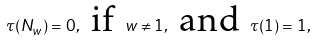Convert formula to latex. <formula><loc_0><loc_0><loc_500><loc_500>\tau ( N _ { w } ) = 0 , \text { if } w \neq 1 , \text { and } \tau ( 1 ) = 1 ,</formula> 